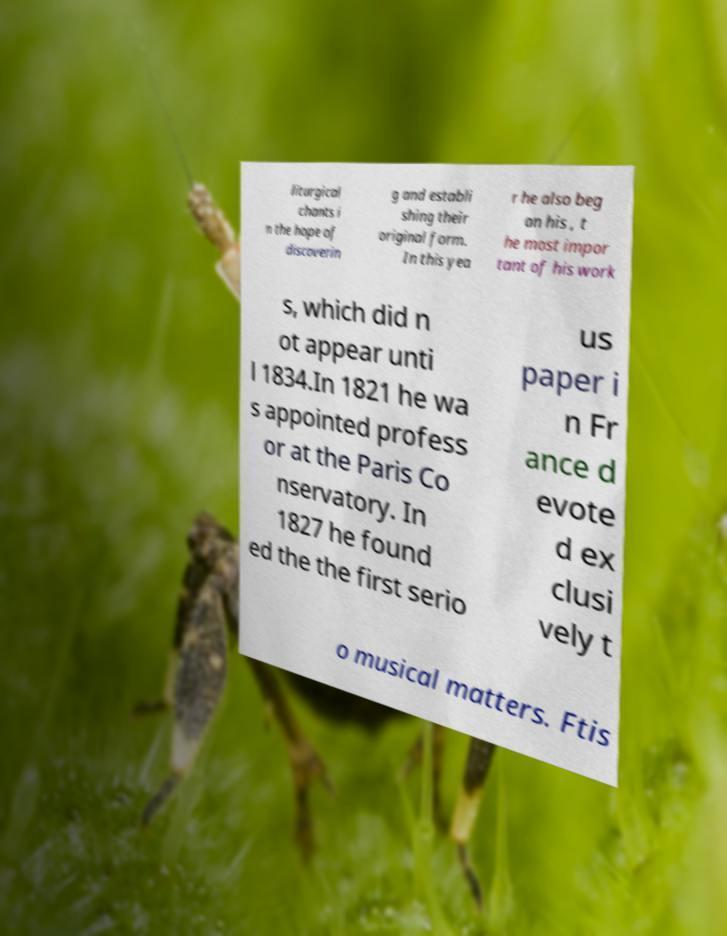Can you read and provide the text displayed in the image?This photo seems to have some interesting text. Can you extract and type it out for me? liturgical chants i n the hope of discoverin g and establi shing their original form. In this yea r he also beg an his , t he most impor tant of his work s, which did n ot appear unti l 1834.In 1821 he wa s appointed profess or at the Paris Co nservatory. In 1827 he found ed the the first serio us paper i n Fr ance d evote d ex clusi vely t o musical matters. Ftis 